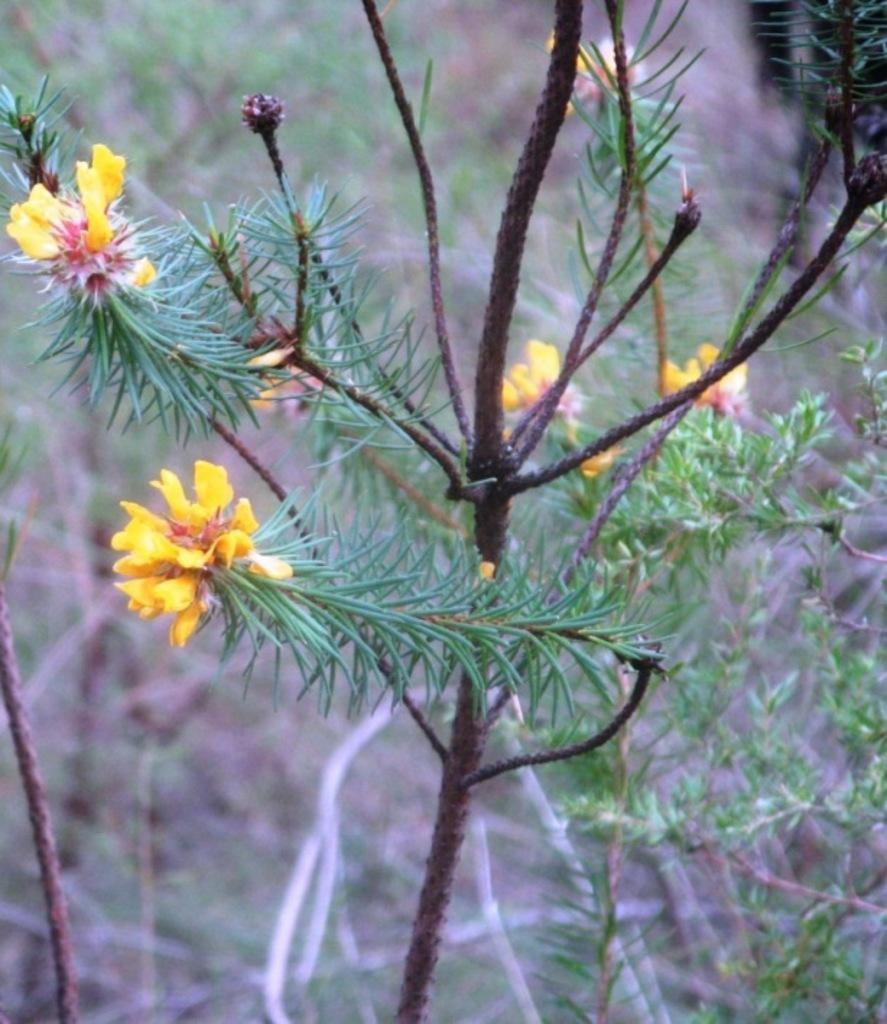What type of vegetation is present in the front of the image? There are flowers in the front of the image. What other plant parts can be seen in the image? There are leaves in the image. How would you describe the background of the image? The background of the image is blurry. What type of afterthought is depicted in the image? There is no afterthought depicted in the image; it features flowers and leaves. How does the rainstorm affect the appearance of the flowers in the image? There is no rainstorm present in the image, so its effect on the flowers cannot be determined. 